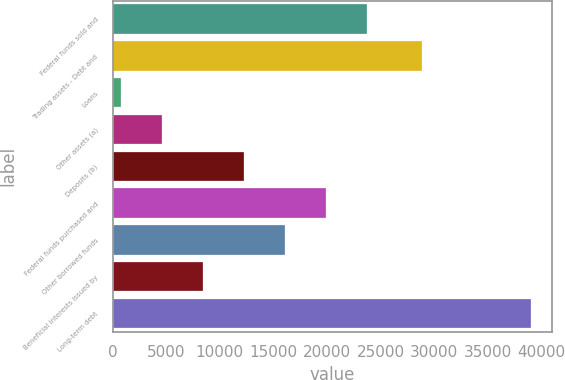Convert chart to OTSL. <chart><loc_0><loc_0><loc_500><loc_500><bar_chart><fcel>Federal funds sold and<fcel>Trading assets - Debt and<fcel>Loans<fcel>Other assets (a)<fcel>Deposits (b)<fcel>Federal funds purchased and<fcel>Other borrowed funds<fcel>Beneficial interests issued by<fcel>Long-term debt<nl><fcel>23718.6<fcel>28841<fcel>759<fcel>4585.6<fcel>12238.8<fcel>19892<fcel>16065.4<fcel>8412.2<fcel>39025<nl></chart> 